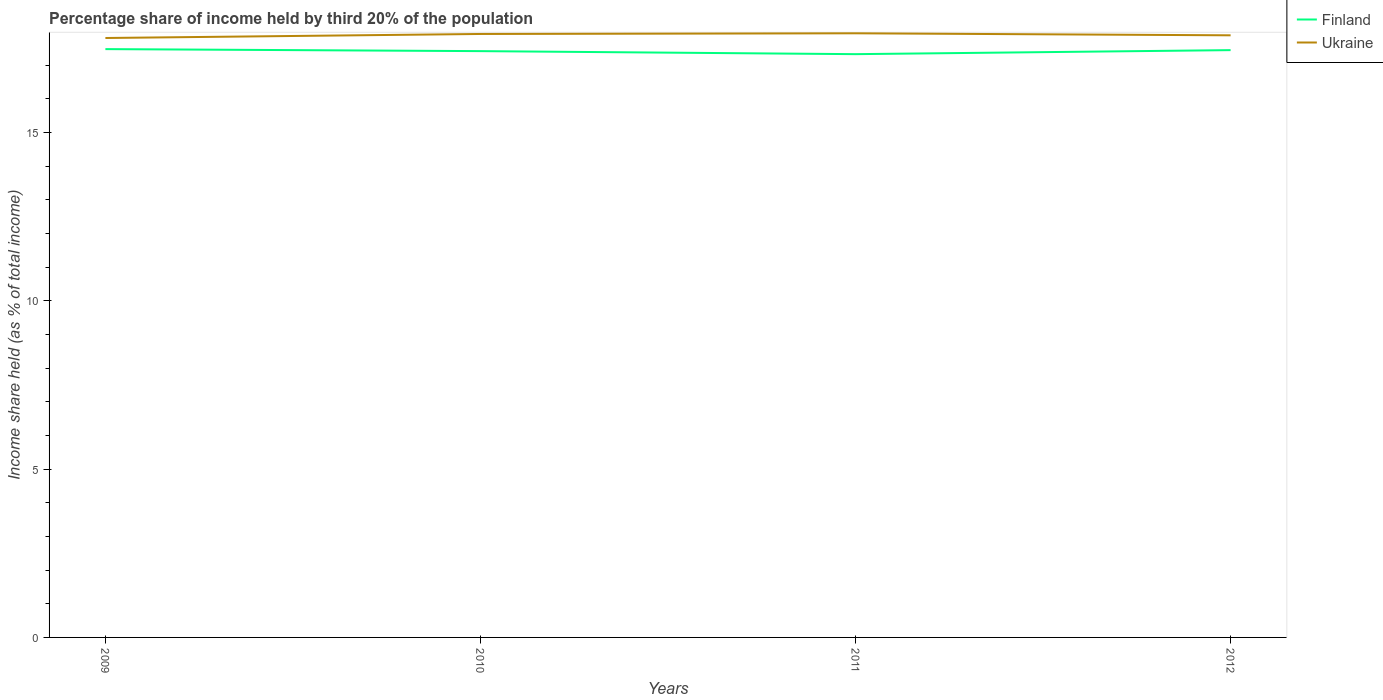Is the number of lines equal to the number of legend labels?
Your response must be concise. Yes. Across all years, what is the maximum share of income held by third 20% of the population in Ukraine?
Your answer should be very brief. 17.81. What is the total share of income held by third 20% of the population in Ukraine in the graph?
Provide a succinct answer. -0.12. What is the difference between the highest and the second highest share of income held by third 20% of the population in Finland?
Offer a very short reply. 0.15. What is the difference between the highest and the lowest share of income held by third 20% of the population in Finland?
Offer a very short reply. 2. Is the share of income held by third 20% of the population in Finland strictly greater than the share of income held by third 20% of the population in Ukraine over the years?
Provide a short and direct response. Yes. Does the graph contain any zero values?
Keep it short and to the point. No. Does the graph contain grids?
Offer a terse response. No. How many legend labels are there?
Keep it short and to the point. 2. What is the title of the graph?
Offer a terse response. Percentage share of income held by third 20% of the population. Does "France" appear as one of the legend labels in the graph?
Your answer should be very brief. No. What is the label or title of the X-axis?
Give a very brief answer. Years. What is the label or title of the Y-axis?
Your answer should be very brief. Income share held (as % of total income). What is the Income share held (as % of total income) of Finland in 2009?
Ensure brevity in your answer.  17.48. What is the Income share held (as % of total income) of Ukraine in 2009?
Keep it short and to the point. 17.81. What is the Income share held (as % of total income) of Finland in 2010?
Your response must be concise. 17.42. What is the Income share held (as % of total income) in Ukraine in 2010?
Give a very brief answer. 17.93. What is the Income share held (as % of total income) in Finland in 2011?
Keep it short and to the point. 17.33. What is the Income share held (as % of total income) in Ukraine in 2011?
Provide a succinct answer. 17.95. What is the Income share held (as % of total income) in Finland in 2012?
Keep it short and to the point. 17.45. What is the Income share held (as % of total income) of Ukraine in 2012?
Provide a short and direct response. 17.89. Across all years, what is the maximum Income share held (as % of total income) of Finland?
Keep it short and to the point. 17.48. Across all years, what is the maximum Income share held (as % of total income) of Ukraine?
Give a very brief answer. 17.95. Across all years, what is the minimum Income share held (as % of total income) of Finland?
Your response must be concise. 17.33. Across all years, what is the minimum Income share held (as % of total income) in Ukraine?
Ensure brevity in your answer.  17.81. What is the total Income share held (as % of total income) of Finland in the graph?
Provide a short and direct response. 69.68. What is the total Income share held (as % of total income) in Ukraine in the graph?
Your response must be concise. 71.58. What is the difference between the Income share held (as % of total income) in Ukraine in 2009 and that in 2010?
Provide a succinct answer. -0.12. What is the difference between the Income share held (as % of total income) of Finland in 2009 and that in 2011?
Ensure brevity in your answer.  0.15. What is the difference between the Income share held (as % of total income) of Ukraine in 2009 and that in 2011?
Keep it short and to the point. -0.14. What is the difference between the Income share held (as % of total income) of Finland in 2009 and that in 2012?
Keep it short and to the point. 0.03. What is the difference between the Income share held (as % of total income) in Ukraine in 2009 and that in 2012?
Keep it short and to the point. -0.08. What is the difference between the Income share held (as % of total income) of Finland in 2010 and that in 2011?
Offer a terse response. 0.09. What is the difference between the Income share held (as % of total income) of Ukraine in 2010 and that in 2011?
Provide a short and direct response. -0.02. What is the difference between the Income share held (as % of total income) in Finland in 2010 and that in 2012?
Provide a succinct answer. -0.03. What is the difference between the Income share held (as % of total income) in Finland in 2011 and that in 2012?
Offer a very short reply. -0.12. What is the difference between the Income share held (as % of total income) of Ukraine in 2011 and that in 2012?
Provide a succinct answer. 0.06. What is the difference between the Income share held (as % of total income) in Finland in 2009 and the Income share held (as % of total income) in Ukraine in 2010?
Your answer should be compact. -0.45. What is the difference between the Income share held (as % of total income) in Finland in 2009 and the Income share held (as % of total income) in Ukraine in 2011?
Provide a succinct answer. -0.47. What is the difference between the Income share held (as % of total income) of Finland in 2009 and the Income share held (as % of total income) of Ukraine in 2012?
Provide a short and direct response. -0.41. What is the difference between the Income share held (as % of total income) of Finland in 2010 and the Income share held (as % of total income) of Ukraine in 2011?
Your answer should be compact. -0.53. What is the difference between the Income share held (as % of total income) of Finland in 2010 and the Income share held (as % of total income) of Ukraine in 2012?
Provide a succinct answer. -0.47. What is the difference between the Income share held (as % of total income) in Finland in 2011 and the Income share held (as % of total income) in Ukraine in 2012?
Keep it short and to the point. -0.56. What is the average Income share held (as % of total income) of Finland per year?
Make the answer very short. 17.42. What is the average Income share held (as % of total income) of Ukraine per year?
Your answer should be very brief. 17.89. In the year 2009, what is the difference between the Income share held (as % of total income) in Finland and Income share held (as % of total income) in Ukraine?
Offer a terse response. -0.33. In the year 2010, what is the difference between the Income share held (as % of total income) in Finland and Income share held (as % of total income) in Ukraine?
Provide a short and direct response. -0.51. In the year 2011, what is the difference between the Income share held (as % of total income) of Finland and Income share held (as % of total income) of Ukraine?
Give a very brief answer. -0.62. In the year 2012, what is the difference between the Income share held (as % of total income) in Finland and Income share held (as % of total income) in Ukraine?
Your answer should be compact. -0.44. What is the ratio of the Income share held (as % of total income) in Finland in 2009 to that in 2010?
Offer a very short reply. 1. What is the ratio of the Income share held (as % of total income) in Finland in 2009 to that in 2011?
Ensure brevity in your answer.  1.01. What is the ratio of the Income share held (as % of total income) of Ukraine in 2009 to that in 2012?
Provide a short and direct response. 1. What is the ratio of the Income share held (as % of total income) of Finland in 2011 to that in 2012?
Make the answer very short. 0.99. What is the difference between the highest and the second highest Income share held (as % of total income) in Ukraine?
Ensure brevity in your answer.  0.02. What is the difference between the highest and the lowest Income share held (as % of total income) in Finland?
Keep it short and to the point. 0.15. What is the difference between the highest and the lowest Income share held (as % of total income) in Ukraine?
Your answer should be compact. 0.14. 